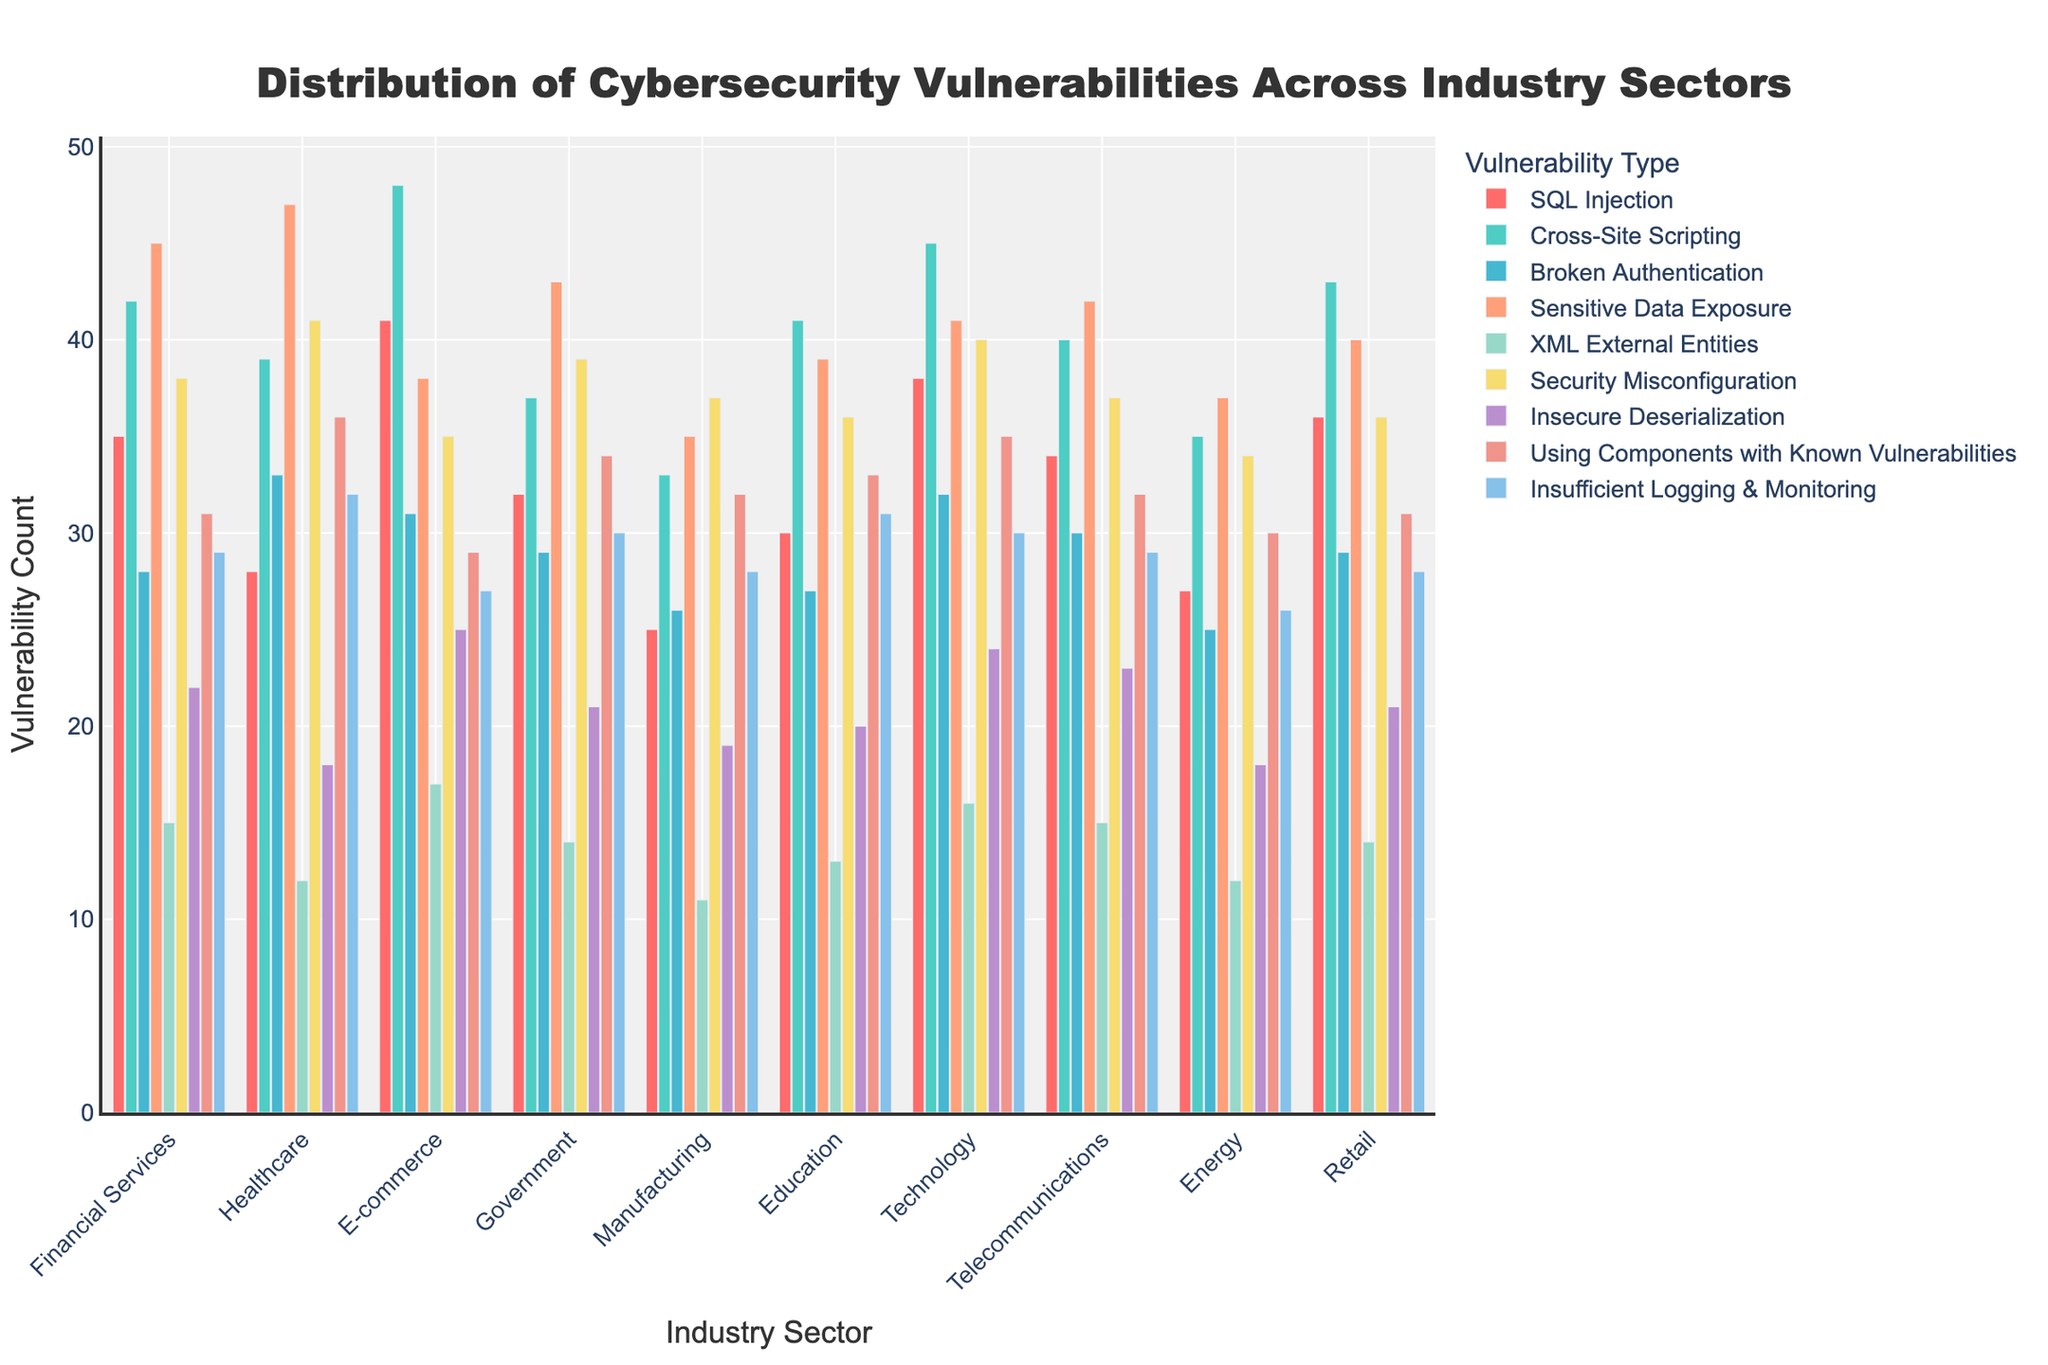Which industry has the highest count of SQL Injection vulnerabilities? Look for the tallest bar in the SQL Injection category. The bars for SQL Injection are represented in red. The E-commerce industry has the tallest red bar with a count of 41.
Answer: E-commerce Which vulnerability is most prevalent in the Healthcare industry? Observe all the bars corresponding to the Healthcare industry and find the tallest one, which represents the most common vulnerability. The tallest bar is for Sensitive Data Exposure which has a count of 47.
Answer: Sensitive Data Exposure How does the count of Cross-Site Scripting vulnerabilities in the Telecommunications sector compare to that in the Technology sector? Compare the height of the bars for Cross-Site Scripting (green bars) for both sectors. Telecommunications has a count of 40 and Technology has a count of 45.
Answer: Telecommunications (40) < Technology (45) What is the combined count of Insecure Deserialization across all industries? Sum the counts for Insecure Deserialization across all industries: 22 + 18 + 25 + 21 + 19 + 20 + 24 + 23 + 18 + 21 = 211.
Answer: 211 How does the count of Security Misconfiguration in the Government sector compare to that in Financial Services? Find the bars for Security Misconfiguration (yellow bars) in both sectors and compare their heights. Government has a count of 39, while Financial Services has a count of 38.
Answer: Government (39) > Financial Services (38) Which industry has the least count of XML External Entities vulnerabilities? The shortest bar for XML External Entities (orange bars) represents the least count. The Manufacturing sector has the shortest bar with a count of 11.
Answer: Manufacturing What is the difference in the count of Using Components with Known Vulnerabilities between the E-commerce and the Energy sectors? Subtract the count for the Energy sector from the count for the E-commerce sector: 29 - 30 = -1.
Answer: -1 How many more vulnerabilities does the Financial Services sector have in Sensitive Data Exposure compared to Security Misconfiguration? Subtract the count for Security Misconfiguration from the count for Sensitive Data Exposure in Financial Services: 45 - 38 = 7.
Answer: 7 What is the average count of vulnerabilities in the Technology sector for the listed categories? Sum the counts for the Technology sector and divide by the number of categories: (38 + 45 + 32 + 41 + 16 + 40 + 24 + 35 + 30)/9 ≈ 33.44.
Answer: 33.44 